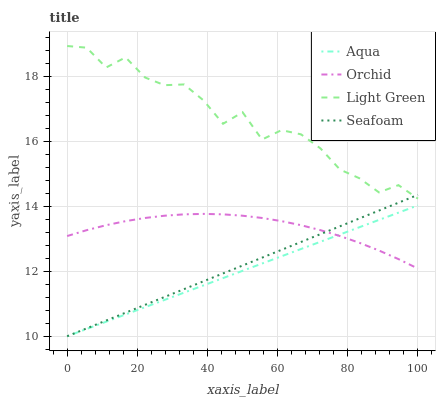Does Aqua have the minimum area under the curve?
Answer yes or no. Yes. Does Light Green have the maximum area under the curve?
Answer yes or no. Yes. Does Seafoam have the minimum area under the curve?
Answer yes or no. No. Does Seafoam have the maximum area under the curve?
Answer yes or no. No. Is Aqua the smoothest?
Answer yes or no. Yes. Is Light Green the roughest?
Answer yes or no. Yes. Is Seafoam the smoothest?
Answer yes or no. No. Is Seafoam the roughest?
Answer yes or no. No. Does Light Green have the lowest value?
Answer yes or no. No. Does Light Green have the highest value?
Answer yes or no. Yes. Does Seafoam have the highest value?
Answer yes or no. No. Is Orchid less than Light Green?
Answer yes or no. Yes. Is Light Green greater than Orchid?
Answer yes or no. Yes. Does Orchid intersect Light Green?
Answer yes or no. No. 